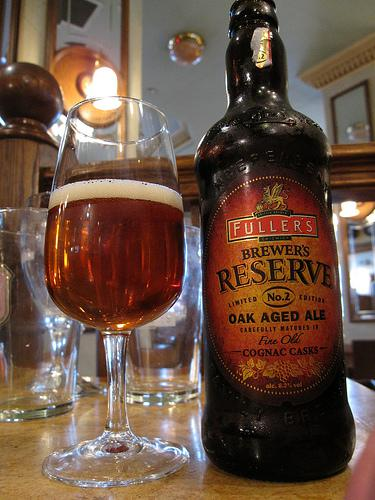Question: what is in the cup next to the bottle?
Choices:
A. Beer.
B. Wine.
C. Soda.
D. Juice.
Answer with the letter. Answer: A Question: what color is the beer bottle?
Choices:
A. Yellow.
B. Clear.
C. Brown.
D. Black.
Answer with the letter. Answer: C Question: who makes this beer?
Choices:
A. Left Coast Brewery.
B. Fuller's.
C. Alpine Brewery.
D. California Brewery.
Answer with the letter. Answer: B Question: how many lights are on?
Choices:
A. Three.
B. Four.
C. Two.
D. Five.
Answer with the letter. Answer: C Question: what are the bubbles at the top of the drink in the cup called?
Choices:
A. Air bubbles.
B. Foam.
C. Carbonation.
D. Head.
Answer with the letter. Answer: D Question: where is this beer matured according to the label?
Choices:
A. Pinot Noir Barrels.
B. France.
C. California.
D. Cognac cases.
Answer with the letter. Answer: D 